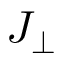<formula> <loc_0><loc_0><loc_500><loc_500>J _ { \perp }</formula> 